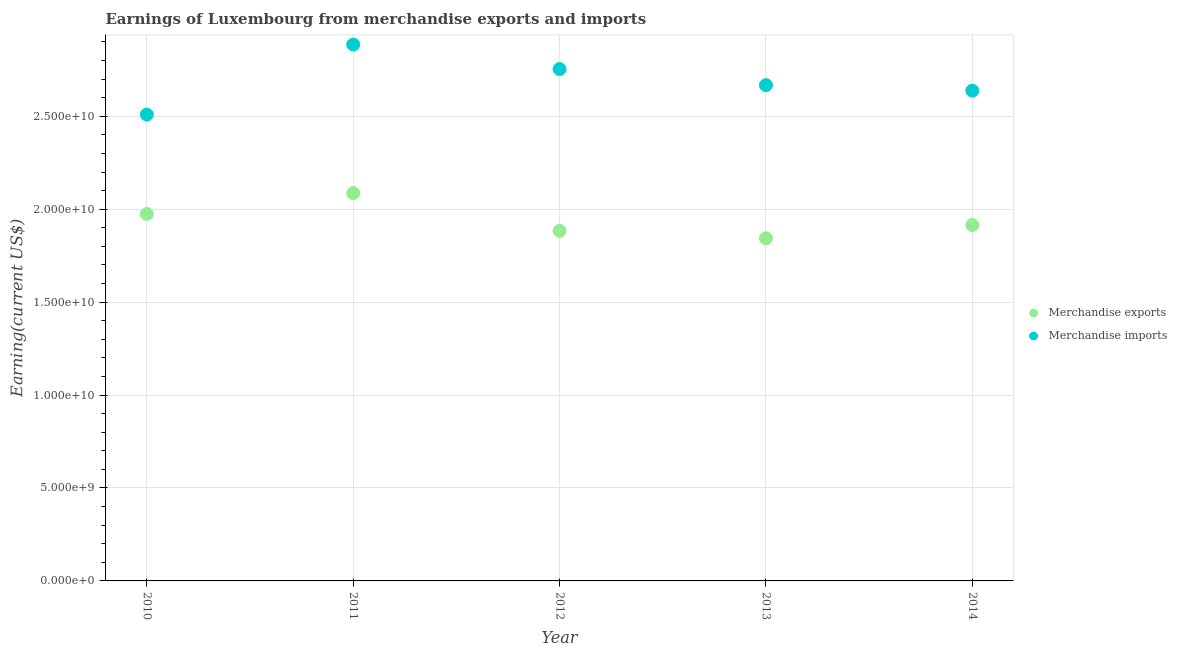Is the number of dotlines equal to the number of legend labels?
Offer a terse response. Yes. What is the earnings from merchandise imports in 2012?
Make the answer very short. 2.75e+1. Across all years, what is the maximum earnings from merchandise exports?
Give a very brief answer. 2.09e+1. Across all years, what is the minimum earnings from merchandise imports?
Ensure brevity in your answer.  2.51e+1. In which year was the earnings from merchandise imports maximum?
Give a very brief answer. 2011. What is the total earnings from merchandise imports in the graph?
Give a very brief answer. 1.35e+11. What is the difference between the earnings from merchandise exports in 2010 and that in 2013?
Give a very brief answer. 1.31e+09. What is the difference between the earnings from merchandise imports in 2012 and the earnings from merchandise exports in 2013?
Offer a very short reply. 9.11e+09. What is the average earnings from merchandise exports per year?
Give a very brief answer. 1.94e+1. In the year 2014, what is the difference between the earnings from merchandise imports and earnings from merchandise exports?
Provide a succinct answer. 7.23e+09. What is the ratio of the earnings from merchandise imports in 2012 to that in 2013?
Your response must be concise. 1.03. Is the earnings from merchandise imports in 2010 less than that in 2014?
Offer a terse response. Yes. What is the difference between the highest and the second highest earnings from merchandise imports?
Ensure brevity in your answer.  1.32e+09. What is the difference between the highest and the lowest earnings from merchandise imports?
Your response must be concise. 3.77e+09. How many dotlines are there?
Your answer should be very brief. 2. How many years are there in the graph?
Keep it short and to the point. 5. What is the difference between two consecutive major ticks on the Y-axis?
Make the answer very short. 5.00e+09. Does the graph contain any zero values?
Your answer should be compact. No. Does the graph contain grids?
Provide a short and direct response. Yes. Where does the legend appear in the graph?
Make the answer very short. Center right. How many legend labels are there?
Provide a short and direct response. 2. How are the legend labels stacked?
Make the answer very short. Vertical. What is the title of the graph?
Provide a short and direct response. Earnings of Luxembourg from merchandise exports and imports. Does "Tetanus" appear as one of the legend labels in the graph?
Keep it short and to the point. No. What is the label or title of the X-axis?
Provide a short and direct response. Year. What is the label or title of the Y-axis?
Provide a short and direct response. Earning(current US$). What is the Earning(current US$) in Merchandise exports in 2010?
Give a very brief answer. 1.97e+1. What is the Earning(current US$) of Merchandise imports in 2010?
Your response must be concise. 2.51e+1. What is the Earning(current US$) in Merchandise exports in 2011?
Give a very brief answer. 2.09e+1. What is the Earning(current US$) in Merchandise imports in 2011?
Offer a very short reply. 2.89e+1. What is the Earning(current US$) in Merchandise exports in 2012?
Make the answer very short. 1.88e+1. What is the Earning(current US$) in Merchandise imports in 2012?
Provide a short and direct response. 2.75e+1. What is the Earning(current US$) in Merchandise exports in 2013?
Offer a very short reply. 1.84e+1. What is the Earning(current US$) in Merchandise imports in 2013?
Provide a short and direct response. 2.67e+1. What is the Earning(current US$) in Merchandise exports in 2014?
Ensure brevity in your answer.  1.92e+1. What is the Earning(current US$) in Merchandise imports in 2014?
Offer a terse response. 2.64e+1. Across all years, what is the maximum Earning(current US$) in Merchandise exports?
Offer a terse response. 2.09e+1. Across all years, what is the maximum Earning(current US$) of Merchandise imports?
Your answer should be compact. 2.89e+1. Across all years, what is the minimum Earning(current US$) of Merchandise exports?
Offer a very short reply. 1.84e+1. Across all years, what is the minimum Earning(current US$) in Merchandise imports?
Offer a very short reply. 2.51e+1. What is the total Earning(current US$) of Merchandise exports in the graph?
Ensure brevity in your answer.  9.70e+1. What is the total Earning(current US$) of Merchandise imports in the graph?
Provide a succinct answer. 1.35e+11. What is the difference between the Earning(current US$) of Merchandise exports in 2010 and that in 2011?
Your response must be concise. -1.12e+09. What is the difference between the Earning(current US$) of Merchandise imports in 2010 and that in 2011?
Provide a short and direct response. -3.77e+09. What is the difference between the Earning(current US$) in Merchandise exports in 2010 and that in 2012?
Offer a terse response. 9.15e+08. What is the difference between the Earning(current US$) of Merchandise imports in 2010 and that in 2012?
Your response must be concise. -2.45e+09. What is the difference between the Earning(current US$) in Merchandise exports in 2010 and that in 2013?
Your response must be concise. 1.31e+09. What is the difference between the Earning(current US$) of Merchandise imports in 2010 and that in 2013?
Provide a short and direct response. -1.58e+09. What is the difference between the Earning(current US$) of Merchandise exports in 2010 and that in 2014?
Offer a terse response. 5.98e+08. What is the difference between the Earning(current US$) in Merchandise imports in 2010 and that in 2014?
Offer a terse response. -1.29e+09. What is the difference between the Earning(current US$) of Merchandise exports in 2011 and that in 2012?
Offer a very short reply. 2.03e+09. What is the difference between the Earning(current US$) of Merchandise imports in 2011 and that in 2012?
Your answer should be very brief. 1.32e+09. What is the difference between the Earning(current US$) in Merchandise exports in 2011 and that in 2013?
Your answer should be compact. 2.43e+09. What is the difference between the Earning(current US$) of Merchandise imports in 2011 and that in 2013?
Your answer should be compact. 2.18e+09. What is the difference between the Earning(current US$) in Merchandise exports in 2011 and that in 2014?
Offer a very short reply. 1.72e+09. What is the difference between the Earning(current US$) of Merchandise imports in 2011 and that in 2014?
Provide a succinct answer. 2.48e+09. What is the difference between the Earning(current US$) of Merchandise exports in 2012 and that in 2013?
Your answer should be very brief. 3.99e+08. What is the difference between the Earning(current US$) in Merchandise imports in 2012 and that in 2013?
Your answer should be compact. 8.65e+08. What is the difference between the Earning(current US$) in Merchandise exports in 2012 and that in 2014?
Your response must be concise. -3.17e+08. What is the difference between the Earning(current US$) in Merchandise imports in 2012 and that in 2014?
Give a very brief answer. 1.16e+09. What is the difference between the Earning(current US$) in Merchandise exports in 2013 and that in 2014?
Make the answer very short. -7.17e+08. What is the difference between the Earning(current US$) of Merchandise imports in 2013 and that in 2014?
Give a very brief answer. 2.98e+08. What is the difference between the Earning(current US$) in Merchandise exports in 2010 and the Earning(current US$) in Merchandise imports in 2011?
Offer a terse response. -9.11e+09. What is the difference between the Earning(current US$) in Merchandise exports in 2010 and the Earning(current US$) in Merchandise imports in 2012?
Offer a terse response. -7.79e+09. What is the difference between the Earning(current US$) in Merchandise exports in 2010 and the Earning(current US$) in Merchandise imports in 2013?
Keep it short and to the point. -6.93e+09. What is the difference between the Earning(current US$) in Merchandise exports in 2010 and the Earning(current US$) in Merchandise imports in 2014?
Your answer should be compact. -6.63e+09. What is the difference between the Earning(current US$) in Merchandise exports in 2011 and the Earning(current US$) in Merchandise imports in 2012?
Provide a short and direct response. -6.68e+09. What is the difference between the Earning(current US$) of Merchandise exports in 2011 and the Earning(current US$) of Merchandise imports in 2013?
Provide a succinct answer. -5.81e+09. What is the difference between the Earning(current US$) of Merchandise exports in 2011 and the Earning(current US$) of Merchandise imports in 2014?
Ensure brevity in your answer.  -5.51e+09. What is the difference between the Earning(current US$) of Merchandise exports in 2012 and the Earning(current US$) of Merchandise imports in 2013?
Provide a succinct answer. -7.84e+09. What is the difference between the Earning(current US$) in Merchandise exports in 2012 and the Earning(current US$) in Merchandise imports in 2014?
Provide a short and direct response. -7.55e+09. What is the difference between the Earning(current US$) in Merchandise exports in 2013 and the Earning(current US$) in Merchandise imports in 2014?
Your response must be concise. -7.95e+09. What is the average Earning(current US$) of Merchandise exports per year?
Provide a short and direct response. 1.94e+1. What is the average Earning(current US$) in Merchandise imports per year?
Offer a terse response. 2.69e+1. In the year 2010, what is the difference between the Earning(current US$) in Merchandise exports and Earning(current US$) in Merchandise imports?
Offer a very short reply. -5.34e+09. In the year 2011, what is the difference between the Earning(current US$) in Merchandise exports and Earning(current US$) in Merchandise imports?
Ensure brevity in your answer.  -7.99e+09. In the year 2012, what is the difference between the Earning(current US$) in Merchandise exports and Earning(current US$) in Merchandise imports?
Offer a very short reply. -8.71e+09. In the year 2013, what is the difference between the Earning(current US$) in Merchandise exports and Earning(current US$) in Merchandise imports?
Offer a very short reply. -8.24e+09. In the year 2014, what is the difference between the Earning(current US$) in Merchandise exports and Earning(current US$) in Merchandise imports?
Ensure brevity in your answer.  -7.23e+09. What is the ratio of the Earning(current US$) of Merchandise exports in 2010 to that in 2011?
Your answer should be very brief. 0.95. What is the ratio of the Earning(current US$) in Merchandise imports in 2010 to that in 2011?
Offer a terse response. 0.87. What is the ratio of the Earning(current US$) in Merchandise exports in 2010 to that in 2012?
Make the answer very short. 1.05. What is the ratio of the Earning(current US$) in Merchandise imports in 2010 to that in 2012?
Make the answer very short. 0.91. What is the ratio of the Earning(current US$) of Merchandise exports in 2010 to that in 2013?
Offer a terse response. 1.07. What is the ratio of the Earning(current US$) in Merchandise imports in 2010 to that in 2013?
Offer a terse response. 0.94. What is the ratio of the Earning(current US$) of Merchandise exports in 2010 to that in 2014?
Your answer should be compact. 1.03. What is the ratio of the Earning(current US$) of Merchandise imports in 2010 to that in 2014?
Ensure brevity in your answer.  0.95. What is the ratio of the Earning(current US$) of Merchandise exports in 2011 to that in 2012?
Your answer should be very brief. 1.11. What is the ratio of the Earning(current US$) in Merchandise imports in 2011 to that in 2012?
Ensure brevity in your answer.  1.05. What is the ratio of the Earning(current US$) of Merchandise exports in 2011 to that in 2013?
Provide a short and direct response. 1.13. What is the ratio of the Earning(current US$) of Merchandise imports in 2011 to that in 2013?
Your answer should be very brief. 1.08. What is the ratio of the Earning(current US$) in Merchandise exports in 2011 to that in 2014?
Make the answer very short. 1.09. What is the ratio of the Earning(current US$) of Merchandise imports in 2011 to that in 2014?
Offer a very short reply. 1.09. What is the ratio of the Earning(current US$) in Merchandise exports in 2012 to that in 2013?
Offer a very short reply. 1.02. What is the ratio of the Earning(current US$) in Merchandise imports in 2012 to that in 2013?
Make the answer very short. 1.03. What is the ratio of the Earning(current US$) in Merchandise exports in 2012 to that in 2014?
Make the answer very short. 0.98. What is the ratio of the Earning(current US$) in Merchandise imports in 2012 to that in 2014?
Ensure brevity in your answer.  1.04. What is the ratio of the Earning(current US$) in Merchandise exports in 2013 to that in 2014?
Keep it short and to the point. 0.96. What is the ratio of the Earning(current US$) in Merchandise imports in 2013 to that in 2014?
Provide a succinct answer. 1.01. What is the difference between the highest and the second highest Earning(current US$) of Merchandise exports?
Your answer should be very brief. 1.12e+09. What is the difference between the highest and the second highest Earning(current US$) in Merchandise imports?
Your answer should be compact. 1.32e+09. What is the difference between the highest and the lowest Earning(current US$) in Merchandise exports?
Give a very brief answer. 2.43e+09. What is the difference between the highest and the lowest Earning(current US$) in Merchandise imports?
Provide a succinct answer. 3.77e+09. 